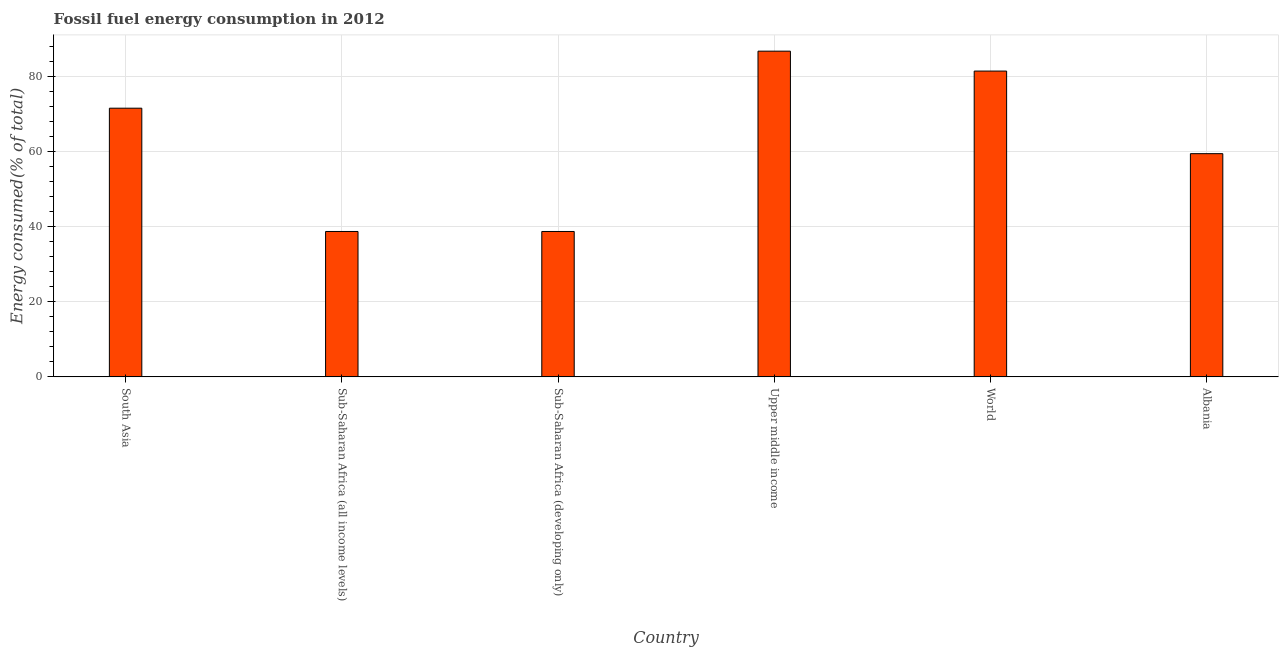What is the title of the graph?
Provide a short and direct response. Fossil fuel energy consumption in 2012. What is the label or title of the X-axis?
Offer a terse response. Country. What is the label or title of the Y-axis?
Ensure brevity in your answer.  Energy consumed(% of total). What is the fossil fuel energy consumption in Albania?
Your answer should be very brief. 59.37. Across all countries, what is the maximum fossil fuel energy consumption?
Ensure brevity in your answer.  86.64. Across all countries, what is the minimum fossil fuel energy consumption?
Give a very brief answer. 38.67. In which country was the fossil fuel energy consumption maximum?
Keep it short and to the point. Upper middle income. In which country was the fossil fuel energy consumption minimum?
Provide a short and direct response. Sub-Saharan Africa (all income levels). What is the sum of the fossil fuel energy consumption?
Provide a succinct answer. 376.16. What is the difference between the fossil fuel energy consumption in South Asia and Sub-Saharan Africa (developing only)?
Provide a short and direct response. 32.79. What is the average fossil fuel energy consumption per country?
Offer a terse response. 62.69. What is the median fossil fuel energy consumption?
Offer a terse response. 65.42. What is the ratio of the fossil fuel energy consumption in Albania to that in Sub-Saharan Africa (developing only)?
Offer a very short reply. 1.53. Is the difference between the fossil fuel energy consumption in Sub-Saharan Africa (developing only) and Upper middle income greater than the difference between any two countries?
Provide a succinct answer. Yes. What is the difference between the highest and the second highest fossil fuel energy consumption?
Offer a terse response. 5.3. Is the sum of the fossil fuel energy consumption in Sub-Saharan Africa (all income levels) and Upper middle income greater than the maximum fossil fuel energy consumption across all countries?
Ensure brevity in your answer.  Yes. What is the difference between the highest and the lowest fossil fuel energy consumption?
Your response must be concise. 47.96. In how many countries, is the fossil fuel energy consumption greater than the average fossil fuel energy consumption taken over all countries?
Provide a short and direct response. 3. Are all the bars in the graph horizontal?
Ensure brevity in your answer.  No. What is the difference between two consecutive major ticks on the Y-axis?
Provide a short and direct response. 20. What is the Energy consumed(% of total) in South Asia?
Give a very brief answer. 71.47. What is the Energy consumed(% of total) of Sub-Saharan Africa (all income levels)?
Your answer should be very brief. 38.67. What is the Energy consumed(% of total) of Sub-Saharan Africa (developing only)?
Offer a terse response. 38.67. What is the Energy consumed(% of total) in Upper middle income?
Offer a terse response. 86.64. What is the Energy consumed(% of total) in World?
Provide a short and direct response. 81.34. What is the Energy consumed(% of total) in Albania?
Give a very brief answer. 59.37. What is the difference between the Energy consumed(% of total) in South Asia and Sub-Saharan Africa (all income levels)?
Your answer should be compact. 32.79. What is the difference between the Energy consumed(% of total) in South Asia and Sub-Saharan Africa (developing only)?
Ensure brevity in your answer.  32.79. What is the difference between the Energy consumed(% of total) in South Asia and Upper middle income?
Your response must be concise. -15.17. What is the difference between the Energy consumed(% of total) in South Asia and World?
Your answer should be compact. -9.87. What is the difference between the Energy consumed(% of total) in South Asia and Albania?
Your answer should be very brief. 12.1. What is the difference between the Energy consumed(% of total) in Sub-Saharan Africa (all income levels) and Upper middle income?
Your answer should be very brief. -47.96. What is the difference between the Energy consumed(% of total) in Sub-Saharan Africa (all income levels) and World?
Ensure brevity in your answer.  -42.67. What is the difference between the Energy consumed(% of total) in Sub-Saharan Africa (all income levels) and Albania?
Make the answer very short. -20.7. What is the difference between the Energy consumed(% of total) in Sub-Saharan Africa (developing only) and Upper middle income?
Your answer should be very brief. -47.96. What is the difference between the Energy consumed(% of total) in Sub-Saharan Africa (developing only) and World?
Give a very brief answer. -42.67. What is the difference between the Energy consumed(% of total) in Sub-Saharan Africa (developing only) and Albania?
Ensure brevity in your answer.  -20.7. What is the difference between the Energy consumed(% of total) in Upper middle income and World?
Give a very brief answer. 5.3. What is the difference between the Energy consumed(% of total) in Upper middle income and Albania?
Your response must be concise. 27.27. What is the difference between the Energy consumed(% of total) in World and Albania?
Provide a short and direct response. 21.97. What is the ratio of the Energy consumed(% of total) in South Asia to that in Sub-Saharan Africa (all income levels)?
Make the answer very short. 1.85. What is the ratio of the Energy consumed(% of total) in South Asia to that in Sub-Saharan Africa (developing only)?
Give a very brief answer. 1.85. What is the ratio of the Energy consumed(% of total) in South Asia to that in Upper middle income?
Make the answer very short. 0.82. What is the ratio of the Energy consumed(% of total) in South Asia to that in World?
Provide a short and direct response. 0.88. What is the ratio of the Energy consumed(% of total) in South Asia to that in Albania?
Ensure brevity in your answer.  1.2. What is the ratio of the Energy consumed(% of total) in Sub-Saharan Africa (all income levels) to that in Upper middle income?
Your answer should be compact. 0.45. What is the ratio of the Energy consumed(% of total) in Sub-Saharan Africa (all income levels) to that in World?
Give a very brief answer. 0.47. What is the ratio of the Energy consumed(% of total) in Sub-Saharan Africa (all income levels) to that in Albania?
Your response must be concise. 0.65. What is the ratio of the Energy consumed(% of total) in Sub-Saharan Africa (developing only) to that in Upper middle income?
Your answer should be very brief. 0.45. What is the ratio of the Energy consumed(% of total) in Sub-Saharan Africa (developing only) to that in World?
Give a very brief answer. 0.47. What is the ratio of the Energy consumed(% of total) in Sub-Saharan Africa (developing only) to that in Albania?
Provide a succinct answer. 0.65. What is the ratio of the Energy consumed(% of total) in Upper middle income to that in World?
Offer a terse response. 1.06. What is the ratio of the Energy consumed(% of total) in Upper middle income to that in Albania?
Ensure brevity in your answer.  1.46. What is the ratio of the Energy consumed(% of total) in World to that in Albania?
Offer a terse response. 1.37. 